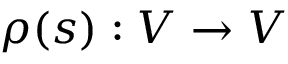<formula> <loc_0><loc_0><loc_500><loc_500>\rho ( s ) \colon V \to V</formula> 